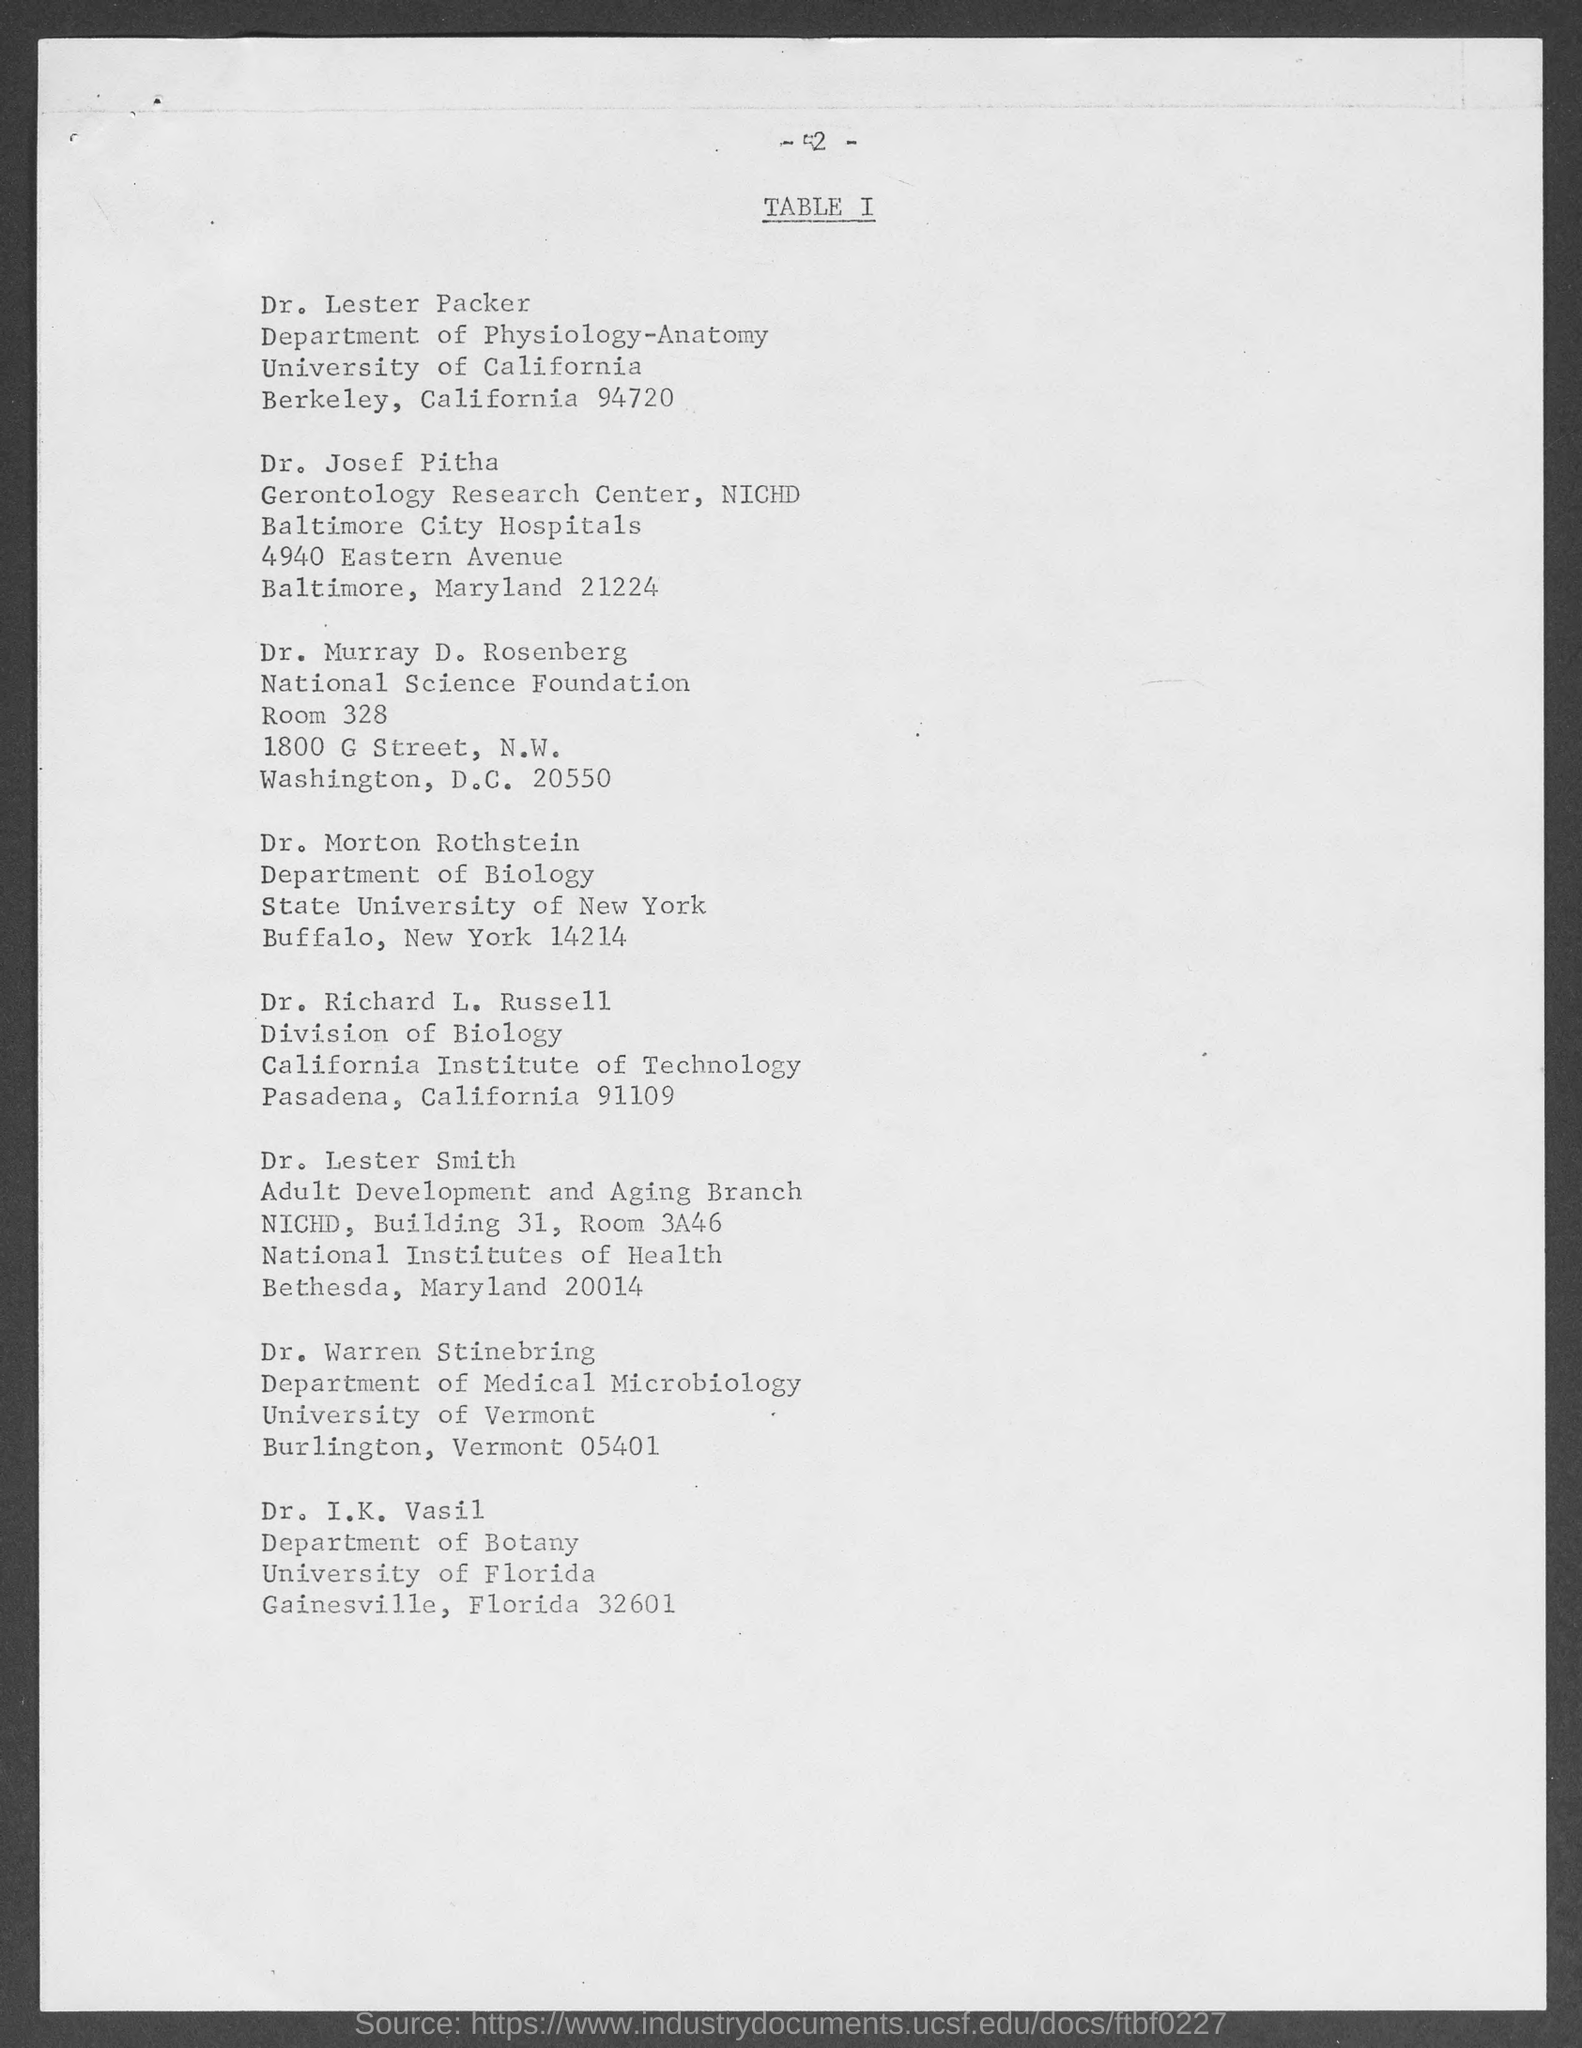What is the page number at top of the page?
Your answer should be very brief. - 2 -. To which university does dr. lester packer belong ?
Your response must be concise. University of California. To which university does dr. morton rothstein belong?
Your answer should be very brief. State University of New York. To which university does dr. i. k. vasil belong ?
Offer a very short reply. University of Florida. To which institute does dr. richard l. russell belong ?
Keep it short and to the point. California Institute of Technology. 